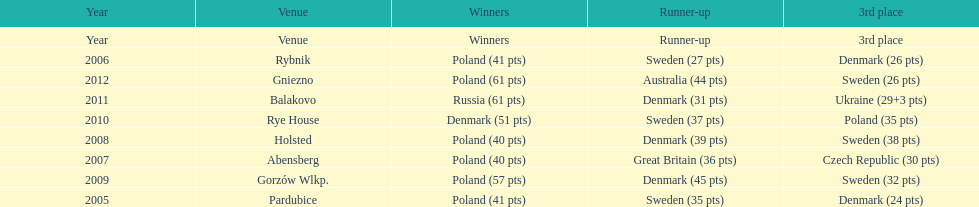In which year did poland first miss out on the top three rankings in the team speedway junior world championship? 2011. 